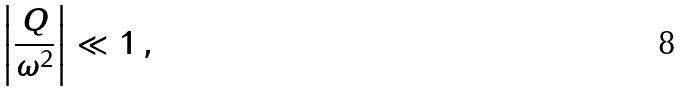Convert formula to latex. <formula><loc_0><loc_0><loc_500><loc_500>\left | \frac { Q } { \omega ^ { 2 } } \right | \ll 1 \, ,</formula> 